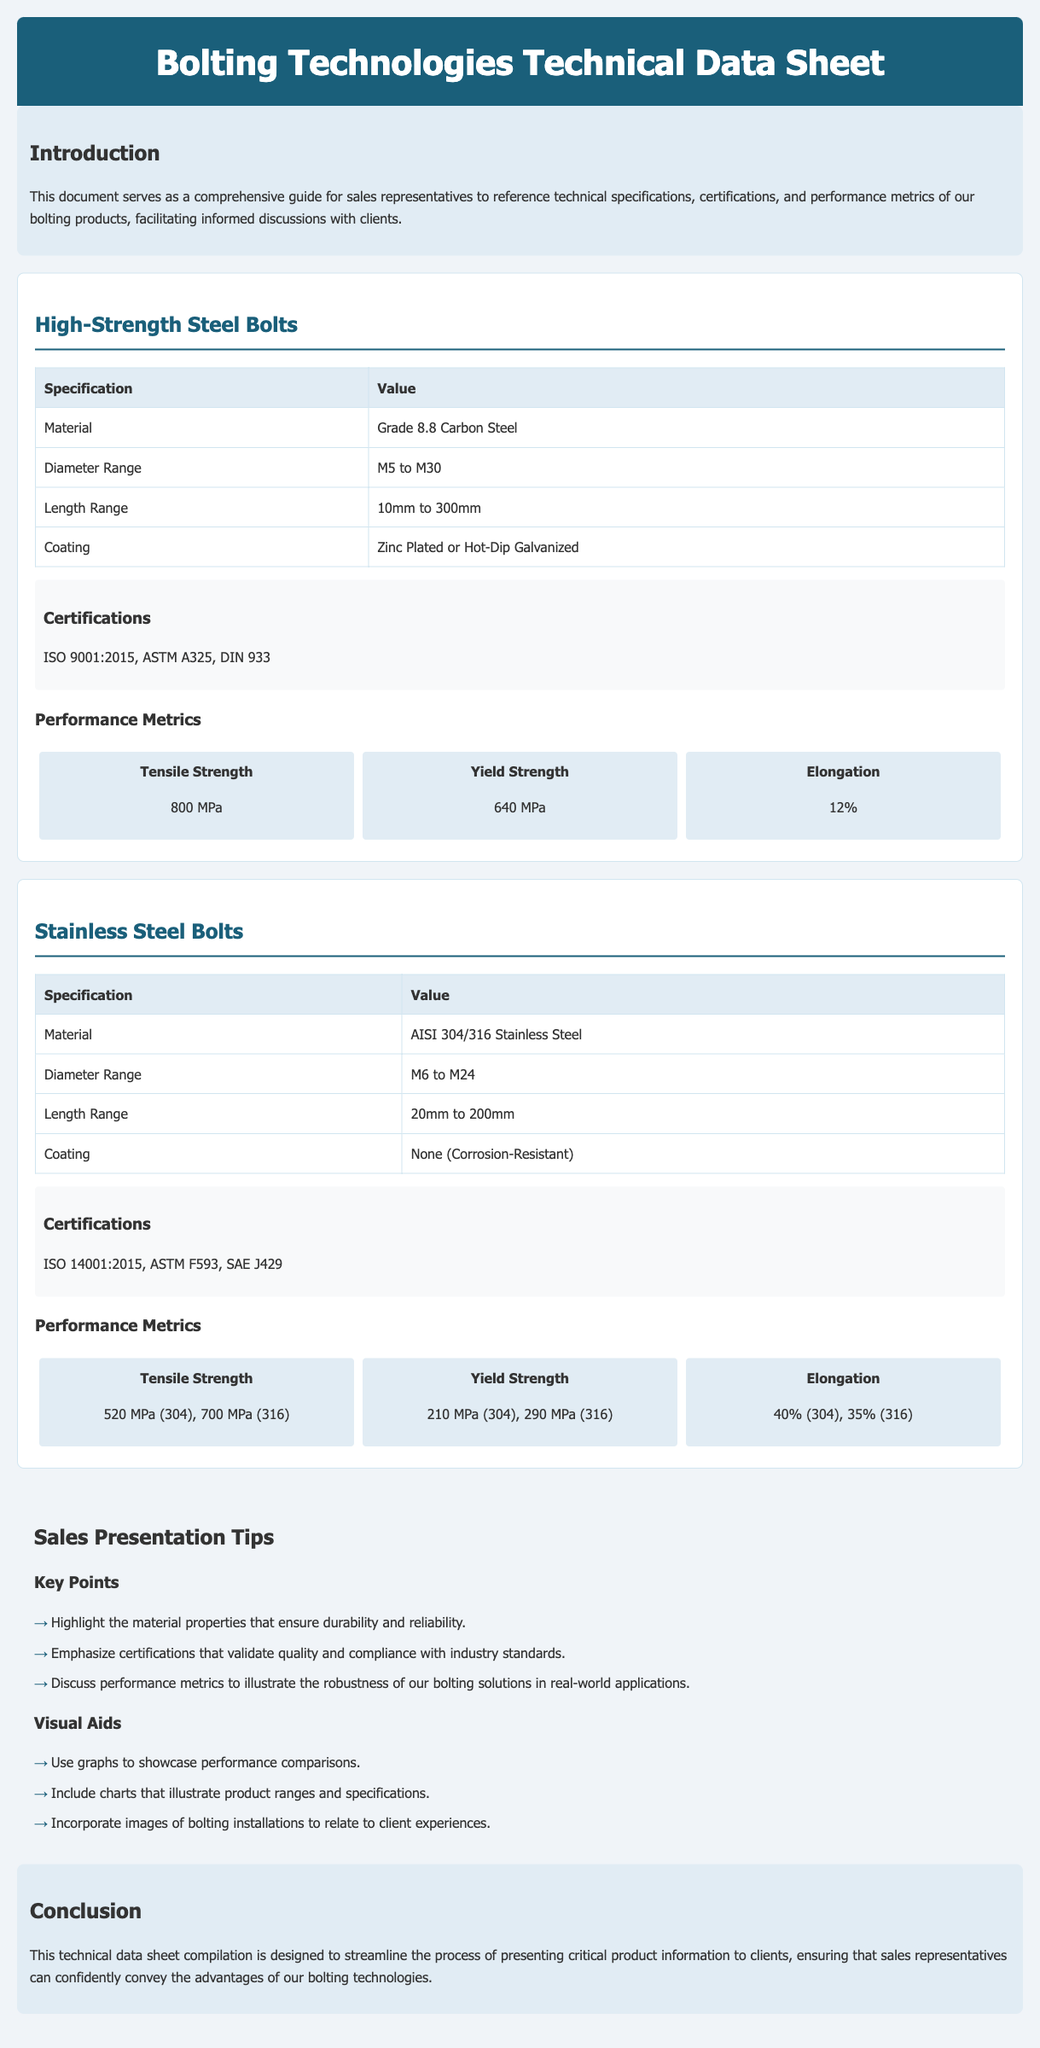What is the material used for High-Strength Steel Bolts? The material specification for High-Strength Steel Bolts is provided in the document, which is Grade 8.8 Carbon Steel.
Answer: Grade 8.8 Carbon Steel What is the diameter range for Stainless Steel Bolts? The document lists the diameter range for Stainless Steel Bolts as specified in the table, which is M6 to M24.
Answer: M6 to M24 What is the ISO certification for High-Strength Steel Bolts? The certifications listed for High-Strength Steel Bolts include ISO 9001:2015, as mentioned in the certifications section.
Answer: ISO 9001:2015 What is the tensile strength of AISI 316 Stainless Steel? The performance metrics specify the tensile strength for AISI 316 Stainless Steel as 700 MPa.
Answer: 700 MPa Which section contains Sales Presentation Tips? The document features a specific section dedicated to tips for sales presentations, labeled "Sales Presentation Tips."
Answer: Sales Presentation Tips How does the yield strength of AISI 304 compare to AISI 316? The document outlines the yield strength for both AISI 304 and AISI 316, indicating that 304 is 210 MPa and 316 is 290 MPa, which requires reasoning to compare.
Answer: 210 MPa (304), 290 MPa (316) What range of lengths is available for High-Strength Steel Bolts? The length range for High-Strength Steel Bolts is provided in the document, which lists it from 10mm to 300mm.
Answer: 10mm to 300mm What background color is used for the introduction section? The introduction section's background color is specified in the document as light blue, identifiable in the style definitions.
Answer: #e1ecf4 